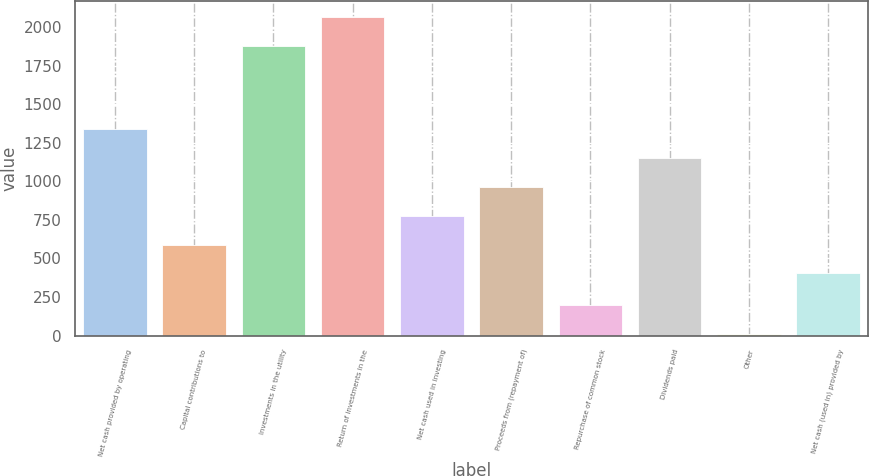<chart> <loc_0><loc_0><loc_500><loc_500><bar_chart><fcel>Net cash provided by operating<fcel>Capital contributions to<fcel>Investments in the utility<fcel>Return of investments in the<fcel>Net cash used in investing<fcel>Proceeds from (repayment of)<fcel>Repurchase of common stock<fcel>Dividends paid<fcel>Other<fcel>Net cash (used in) provided by<nl><fcel>1338.5<fcel>590.1<fcel>1880<fcel>2067.1<fcel>777.2<fcel>964.3<fcel>196.1<fcel>1151.4<fcel>9<fcel>403<nl></chart> 